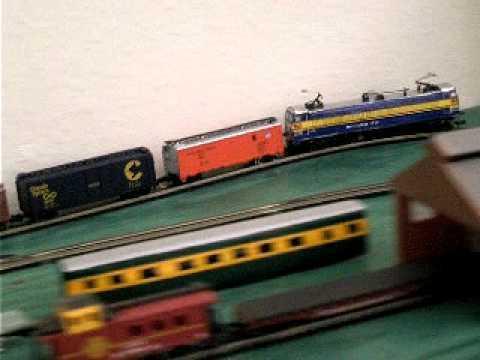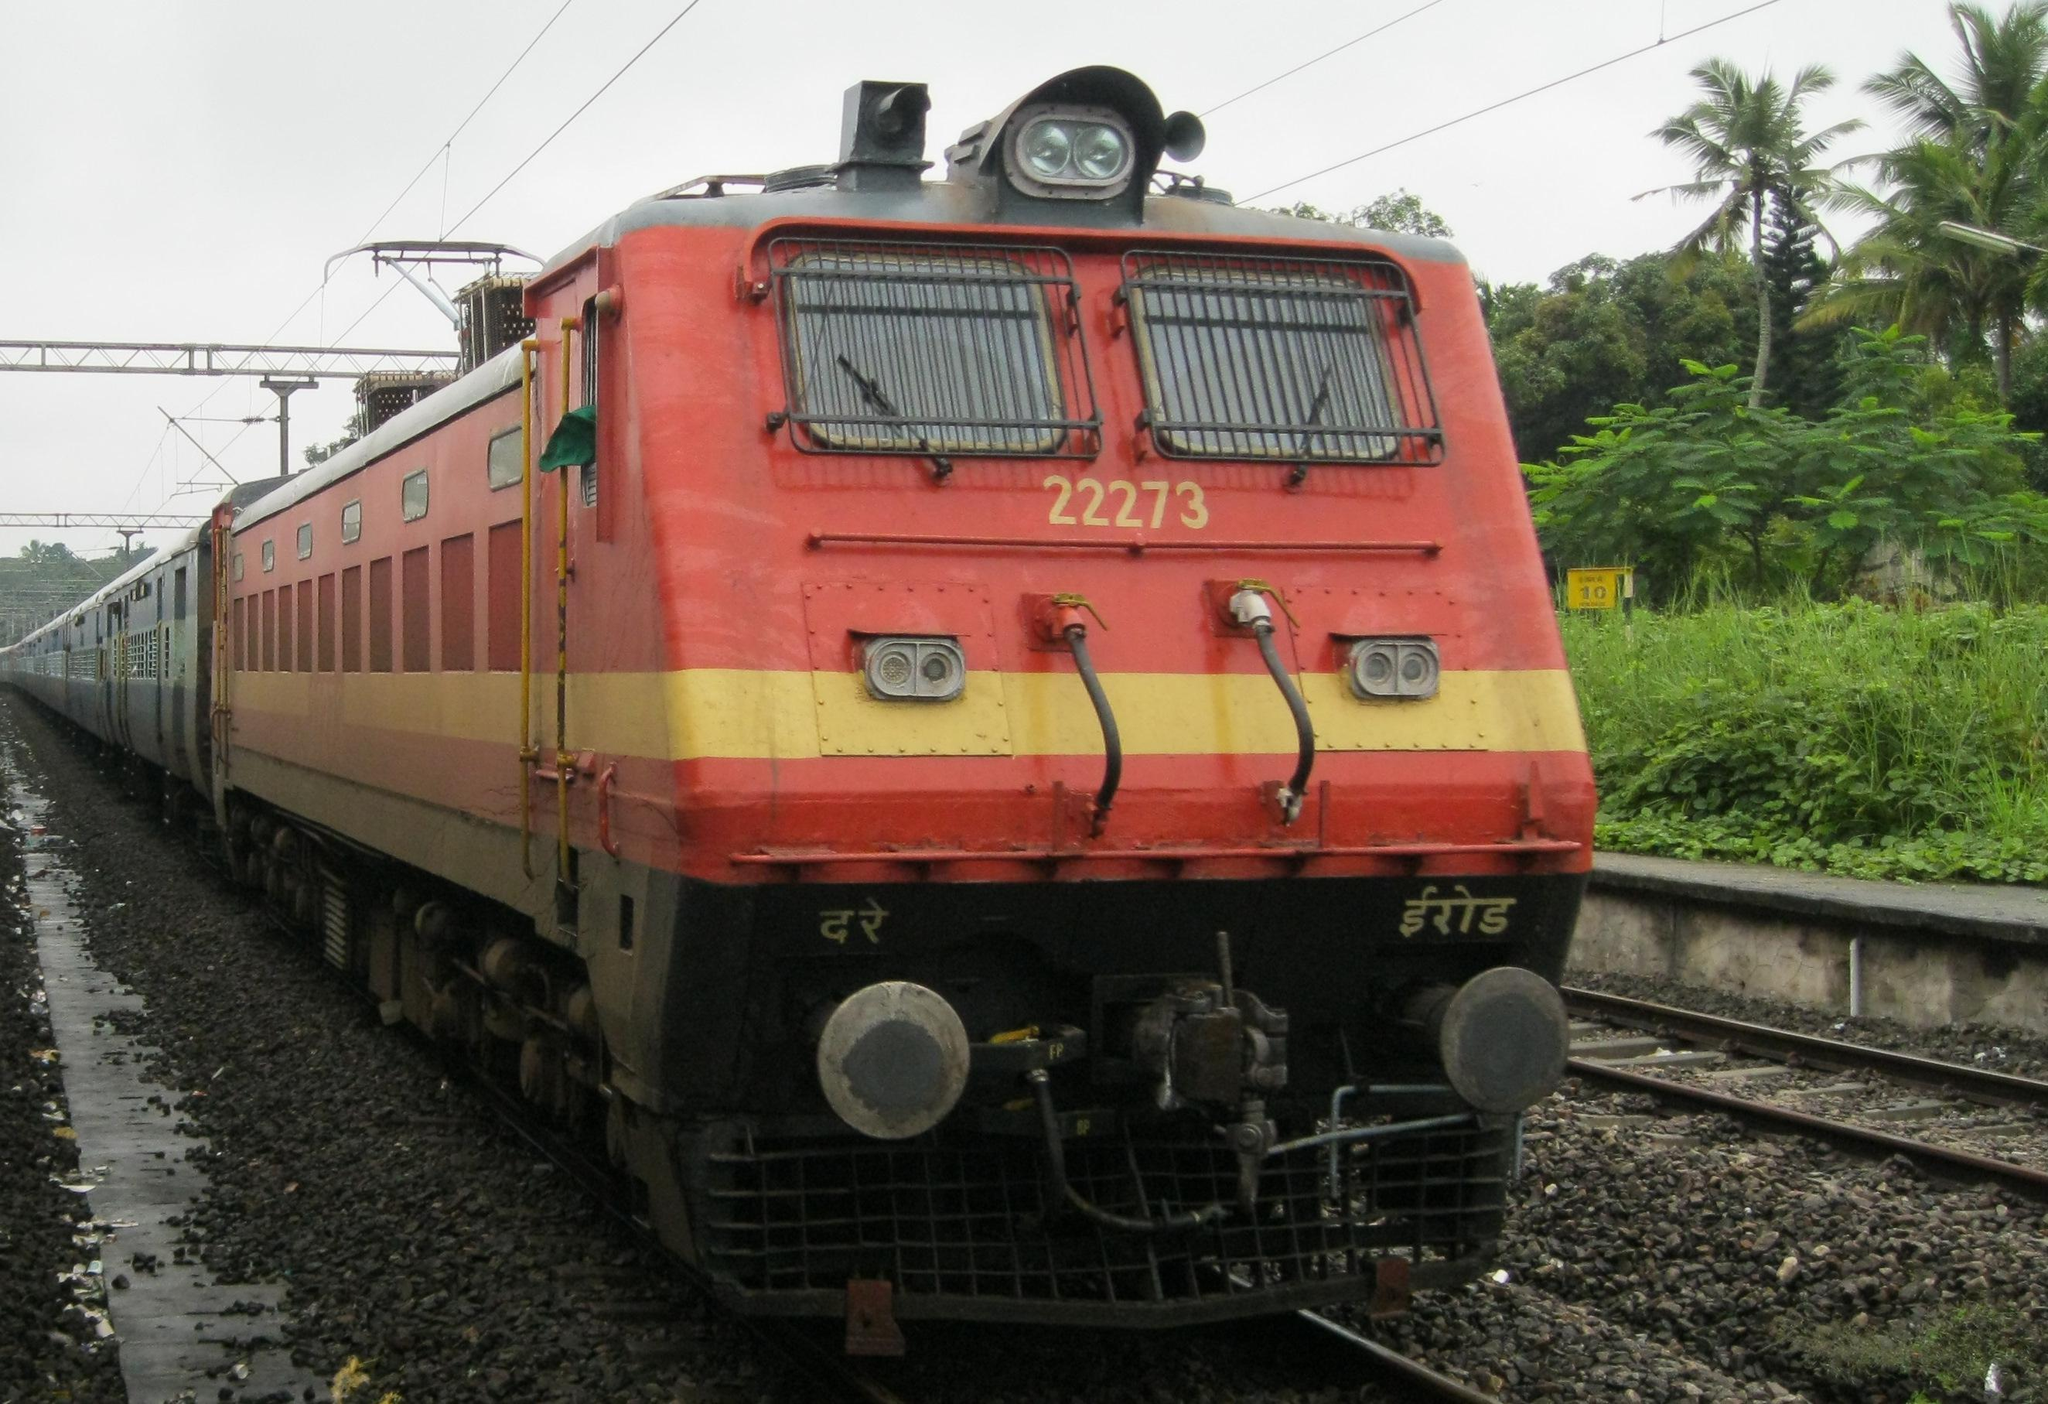The first image is the image on the left, the second image is the image on the right. For the images shown, is this caption "Power lines can be seen above the train in the image on the right." true? Answer yes or no. Yes. 